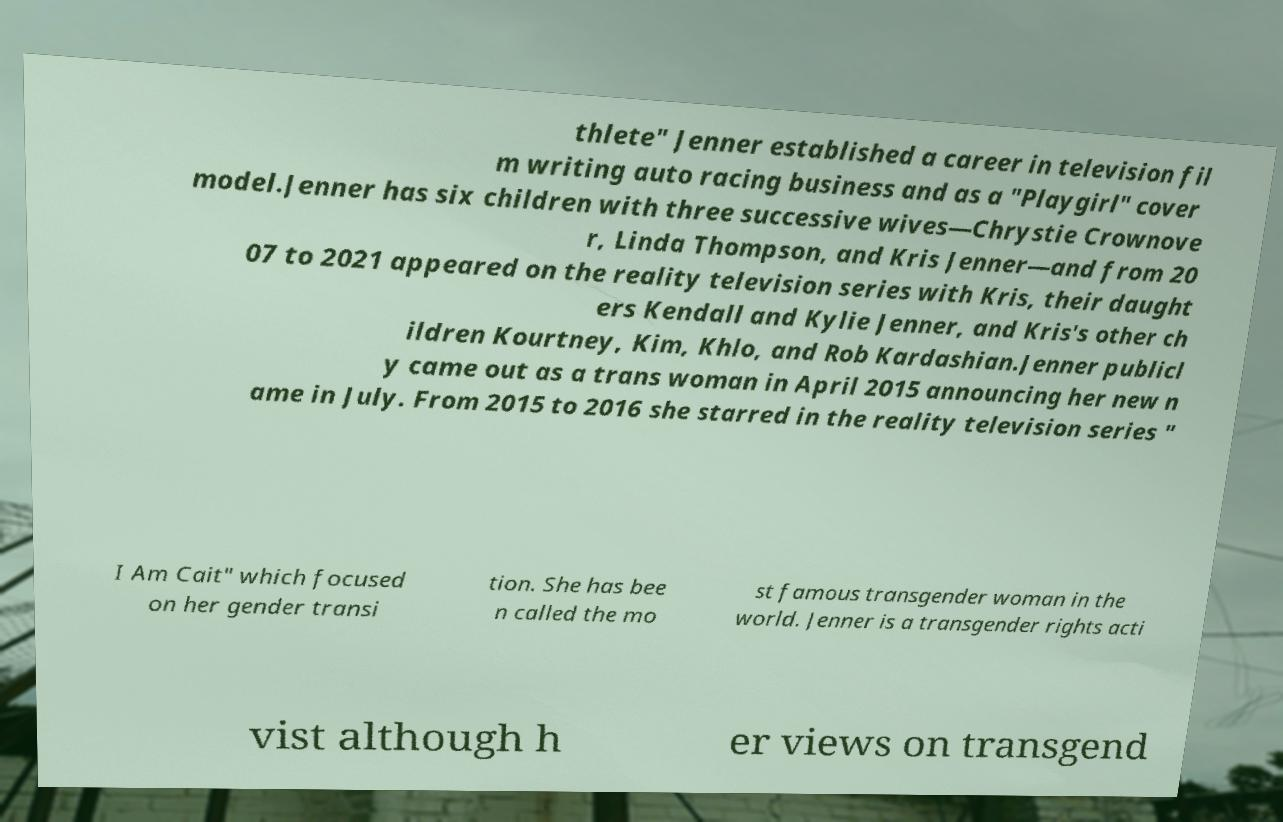Could you assist in decoding the text presented in this image and type it out clearly? thlete" Jenner established a career in television fil m writing auto racing business and as a "Playgirl" cover model.Jenner has six children with three successive wives—Chrystie Crownove r, Linda Thompson, and Kris Jenner—and from 20 07 to 2021 appeared on the reality television series with Kris, their daught ers Kendall and Kylie Jenner, and Kris's other ch ildren Kourtney, Kim, Khlo, and Rob Kardashian.Jenner publicl y came out as a trans woman in April 2015 announcing her new n ame in July. From 2015 to 2016 she starred in the reality television series " I Am Cait" which focused on her gender transi tion. She has bee n called the mo st famous transgender woman in the world. Jenner is a transgender rights acti vist although h er views on transgend 